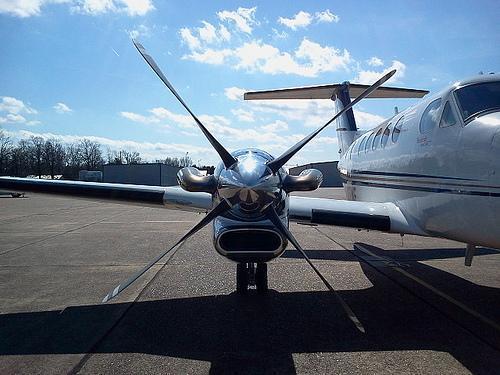How many airplanes are visible in the picture?
Give a very brief answer. 1. 